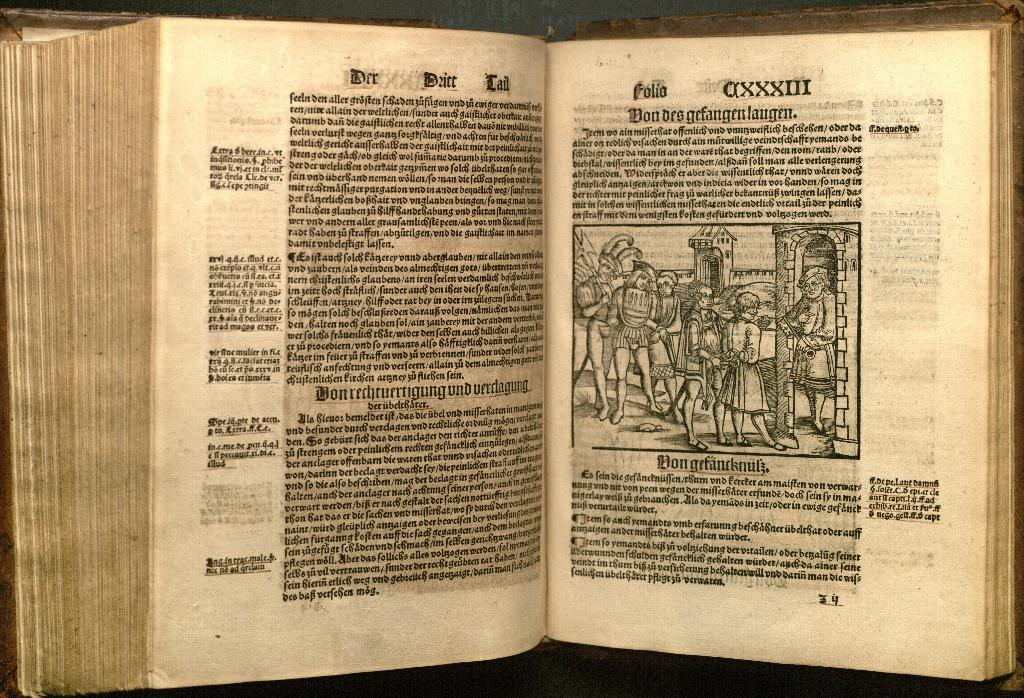<image>
Summarize the visual content of the image. A book written in Roman with the numerals AXXXIII on the top of the page. 